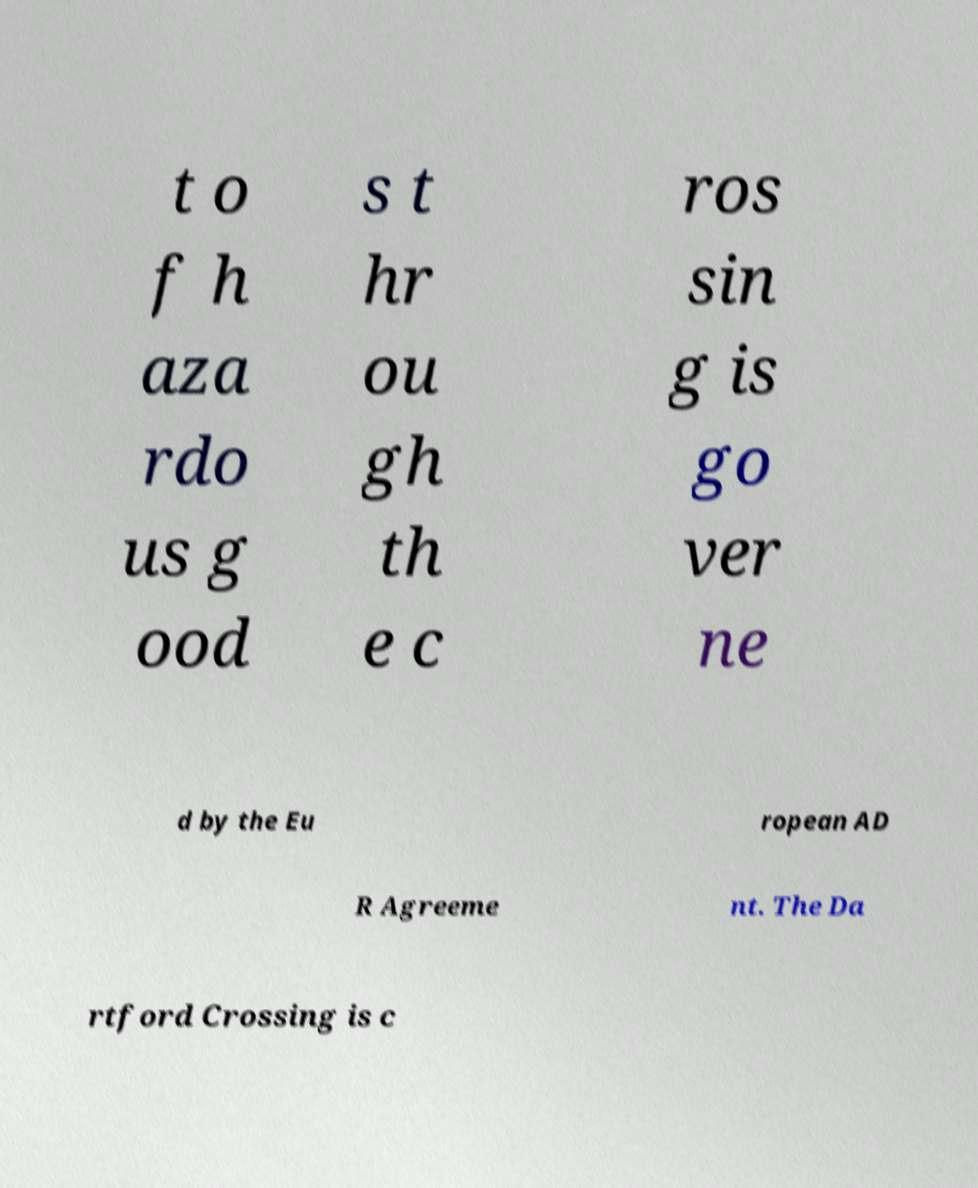For documentation purposes, I need the text within this image transcribed. Could you provide that? t o f h aza rdo us g ood s t hr ou gh th e c ros sin g is go ver ne d by the Eu ropean AD R Agreeme nt. The Da rtford Crossing is c 